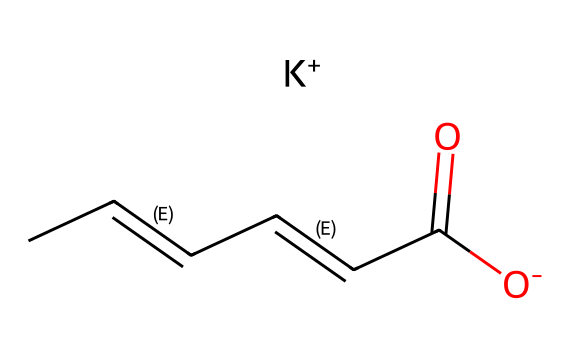What is the overall charge of potassium sorbate? The chemical structure shows the presence of a potassium ion (K+) which indicates that the overall charge of potassium sorbate is positive.
Answer: positive How many carbon atoms are present in potassium sorbate? By analyzing the SMILES representation, we can count the number of carbon (C) symbols. There are 6 total carbon atoms present in the structure.
Answer: 6 What type of functional group is present in potassium sorbate? The structure contains a carboxylic acid group (indicated by the -COO- in the SMILES), which characterizes potassium sorbate as having a carboxyl functional group.
Answer: carboxyl Which element is represented by the symbol "K" in potassium sorbate? The "K" in the SMILES notation denotes potassium, which is a key component of potassium sorbate.
Answer: potassium How many double bonds are present in potassium sorbate? The branch "C/C=C/C=C/" in the SMILES indicates the presence of two double bonds between the carbon atoms.
Answer: 2 What is the role of potassium sorbate in food preservation? Potassium sorbate acts as a preservative, inhibiting mold and yeast growth in various food products, thus extending their shelf life.
Answer: preservative What does the "O-" indicate in the molecular structure of potassium sorbate? The "O-" shows that the carboxylic acid has lost a proton (H+), resulting in a negatively charged ion (anionic form) of sorbate, which is important for its effectiveness as a preservative.
Answer: negatively charged ion 